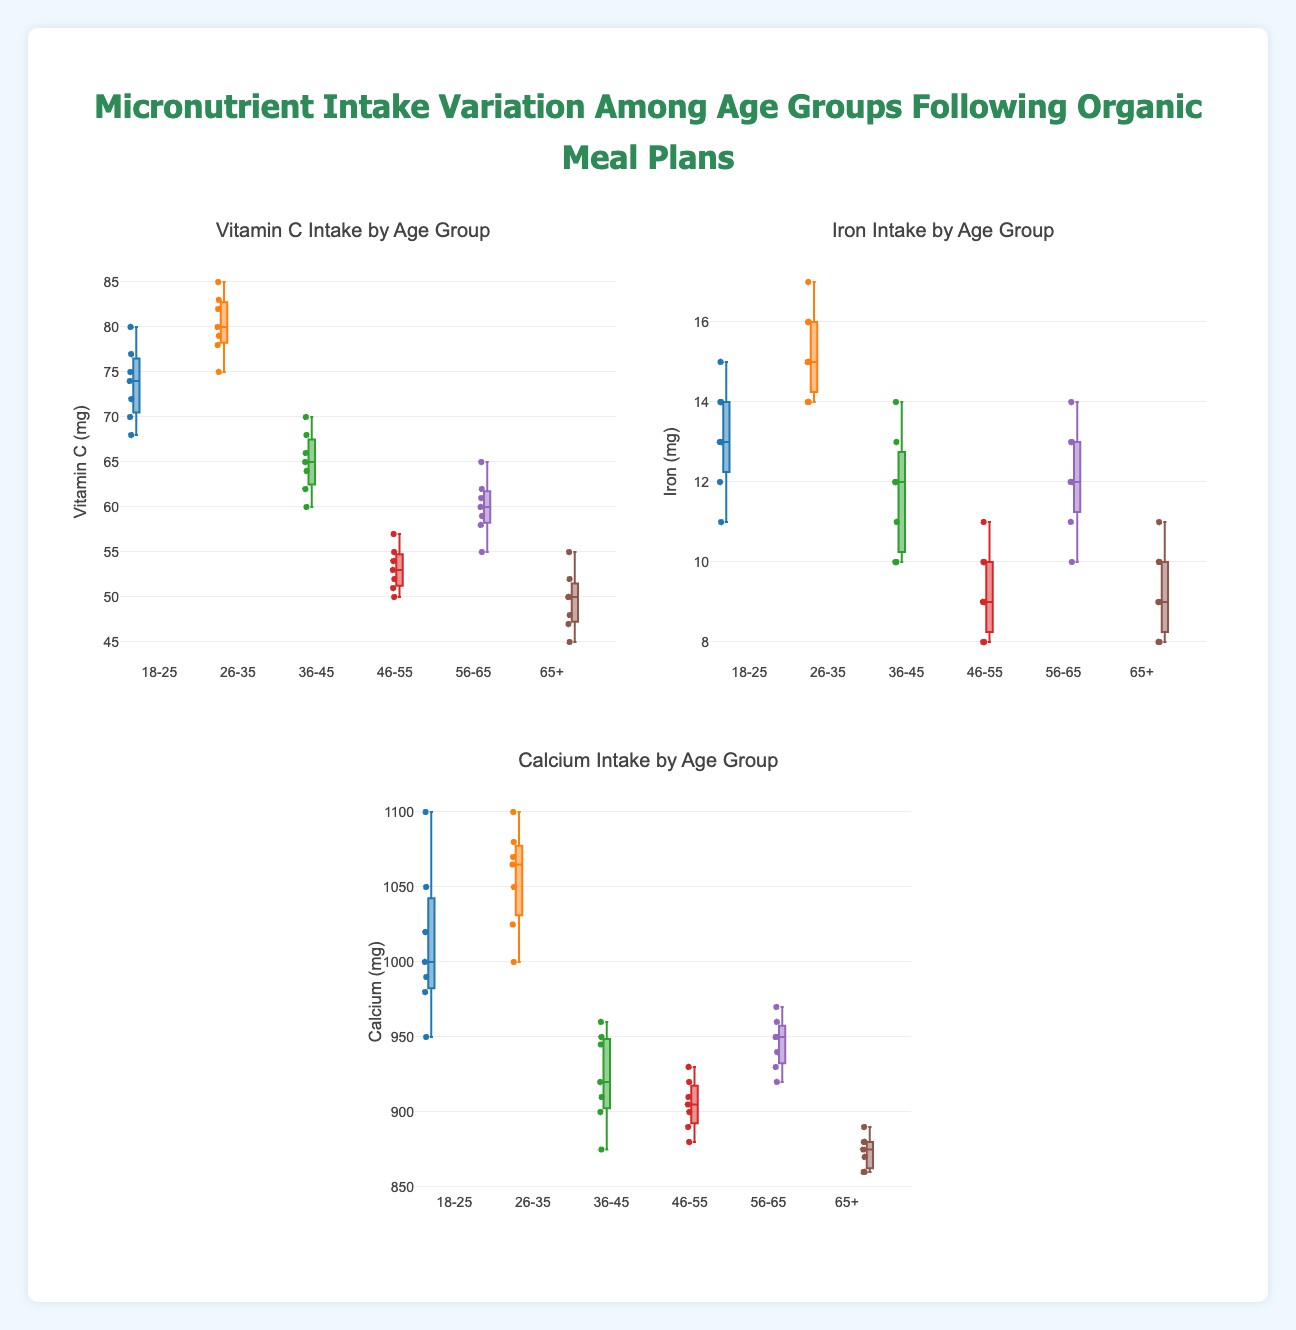What is the median intake of Vitamin C for the 18-25 age group? Locate the box plot for Vitamin C in the 18-25 age group. The median is indicated by the line inside the box.
Answer: 74 mg Which age group has the highest median intake of Iron? Compare the median lines (inside the boxes) for Iron intake across all age groups. The highest median line indicates the highest median intake.
Answer: 26-35 Between which two age groups is the difference in median Calcium intake the greatest? Identify and compare the median lines inside the boxes for Calcium intake across all age groups. The age groups with the most contrast in median values represent the greatest difference.
Answer: 26-35 and 65+ What is the interquartile range (IQR) of Vitamin C intake for the 46-55 age group? The IQR is the range between the first (Q1) and third quartiles (Q3) of the box. For Vitamin C in the 46-55 age group, find the values at the bottom and top of the box.
Answer: 4 mg Which age group has the greatest variability in Calcium intake? Variability can be inferred by observing the length of the whiskers and the spread of data points outside the boxes. Compare the ranges for Calcium across age groups.
Answer: 18-25 Does the 65+ age group have any outliers in Iron intake? Outliers are data points outside the whiskers. Check the Iron intake box plot for 65+ to see if any points lie beyond the whiskers.
Answer: No How does the median intake of Vitamin C for the 56-65 age group compare to the median intake of Iron for the same age group? Locate the median lines on the box plots for Vitamin C and Iron in the 56-65 age group and compare them directly.
Answer: Higher for Vitamin C Which micronutrient shows the least variation across all age groups? Identify which box plots have the smallest overall spread (boxes and whiskers) across all age groups.
Answer: Iron For the age group 36-45, how does the variability in Vitamin C intake compare to Iron intake? Compare the box lengths and whisker ranges for Vitamin C and Iron in the 36-45 age group. Greater length and range indicate higher variability.
Answer: Greater for Vitamin C 